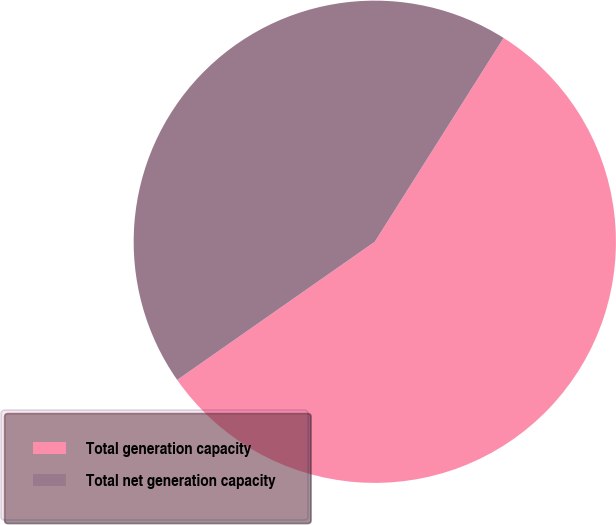Convert chart to OTSL. <chart><loc_0><loc_0><loc_500><loc_500><pie_chart><fcel>Total generation capacity<fcel>Total net generation capacity<nl><fcel>56.32%<fcel>43.68%<nl></chart> 